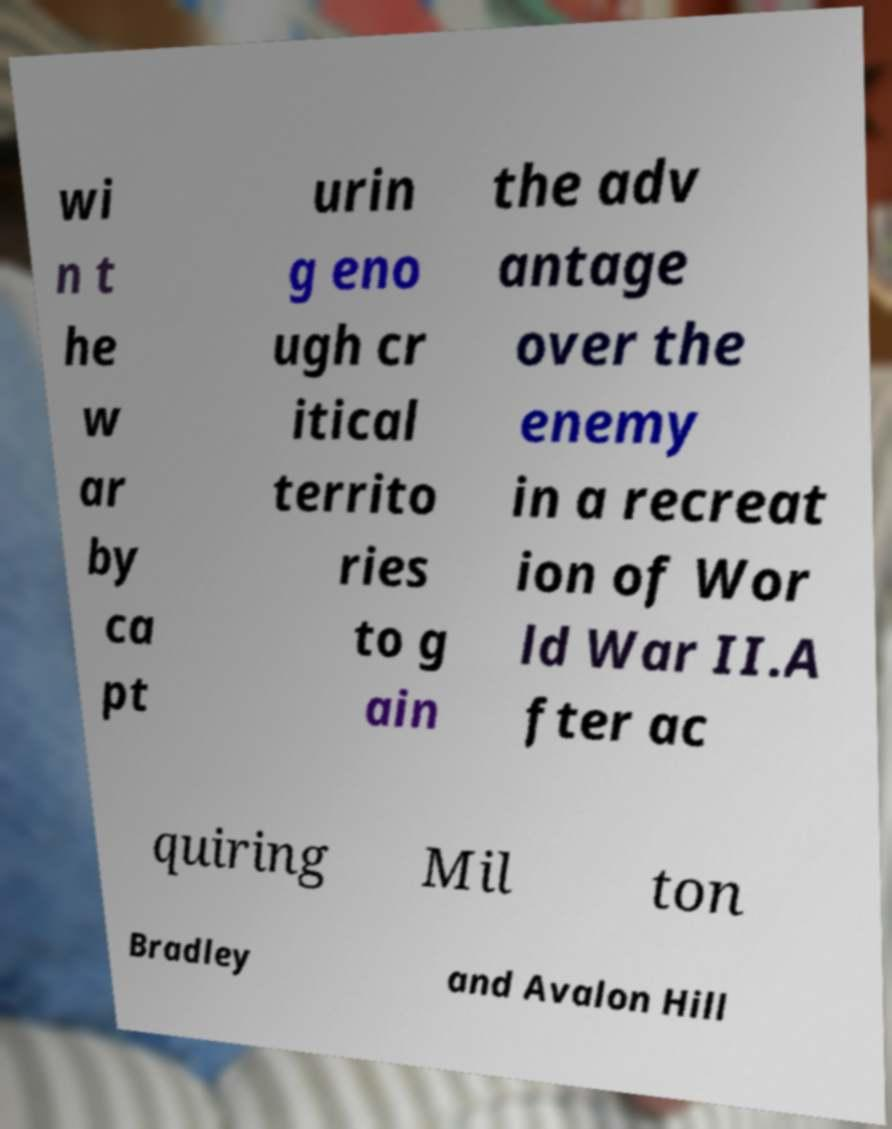Please read and relay the text visible in this image. What does it say? wi n t he w ar by ca pt urin g eno ugh cr itical territo ries to g ain the adv antage over the enemy in a recreat ion of Wor ld War II.A fter ac quiring Mil ton Bradley and Avalon Hill 